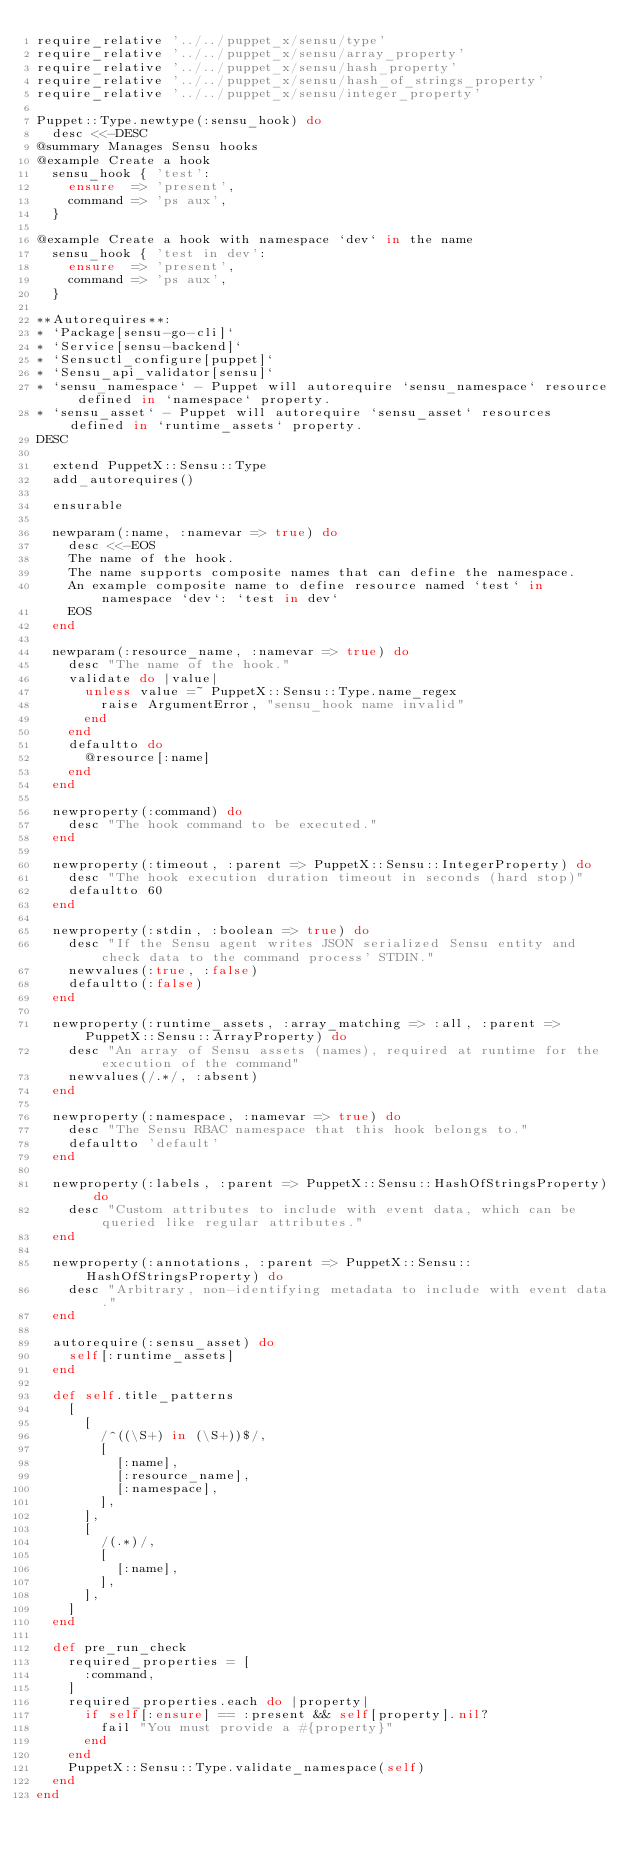Convert code to text. <code><loc_0><loc_0><loc_500><loc_500><_Ruby_>require_relative '../../puppet_x/sensu/type'
require_relative '../../puppet_x/sensu/array_property'
require_relative '../../puppet_x/sensu/hash_property'
require_relative '../../puppet_x/sensu/hash_of_strings_property'
require_relative '../../puppet_x/sensu/integer_property'

Puppet::Type.newtype(:sensu_hook) do
  desc <<-DESC
@summary Manages Sensu hooks
@example Create a hook
  sensu_hook { 'test':
    ensure  => 'present',
    command => 'ps aux',
  }

@example Create a hook with namespace `dev` in the name
  sensu_hook { 'test in dev':
    ensure  => 'present',
    command => 'ps aux',
  }

**Autorequires**:
* `Package[sensu-go-cli]`
* `Service[sensu-backend]`
* `Sensuctl_configure[puppet]`
* `Sensu_api_validator[sensu]`
* `sensu_namespace` - Puppet will autorequire `sensu_namespace` resource defined in `namespace` property.
* `sensu_asset` - Puppet will autorequire `sensu_asset` resources defined in `runtime_assets` property.
DESC

  extend PuppetX::Sensu::Type
  add_autorequires()

  ensurable

  newparam(:name, :namevar => true) do
    desc <<-EOS
    The name of the hook.
    The name supports composite names that can define the namespace.
    An example composite name to define resource named `test` in namespace `dev`: `test in dev`
    EOS
  end

  newparam(:resource_name, :namevar => true) do
    desc "The name of the hook."
    validate do |value|
      unless value =~ PuppetX::Sensu::Type.name_regex
        raise ArgumentError, "sensu_hook name invalid"
      end
    end
    defaultto do
      @resource[:name]
    end
  end

  newproperty(:command) do
    desc "The hook command to be executed."
  end

  newproperty(:timeout, :parent => PuppetX::Sensu::IntegerProperty) do
    desc "The hook execution duration timeout in seconds (hard stop)"
    defaultto 60
  end

  newproperty(:stdin, :boolean => true) do
    desc "If the Sensu agent writes JSON serialized Sensu entity and check data to the command process' STDIN."
    newvalues(:true, :false)
    defaultto(:false)
  end

  newproperty(:runtime_assets, :array_matching => :all, :parent => PuppetX::Sensu::ArrayProperty) do
    desc "An array of Sensu assets (names), required at runtime for the execution of the command"
    newvalues(/.*/, :absent)
  end

  newproperty(:namespace, :namevar => true) do
    desc "The Sensu RBAC namespace that this hook belongs to."
    defaultto 'default'
  end

  newproperty(:labels, :parent => PuppetX::Sensu::HashOfStringsProperty) do
    desc "Custom attributes to include with event data, which can be queried like regular attributes."
  end

  newproperty(:annotations, :parent => PuppetX::Sensu::HashOfStringsProperty) do
    desc "Arbitrary, non-identifying metadata to include with event data."
  end

  autorequire(:sensu_asset) do
    self[:runtime_assets]
  end

  def self.title_patterns
    [
      [
        /^((\S+) in (\S+))$/,
        [
          [:name],
          [:resource_name],
          [:namespace],
        ],
      ],
      [
        /(.*)/,
        [
          [:name],
        ],
      ],
    ]
  end

  def pre_run_check
    required_properties = [
      :command,
    ]
    required_properties.each do |property|
      if self[:ensure] == :present && self[property].nil?
        fail "You must provide a #{property}"
      end
    end
    PuppetX::Sensu::Type.validate_namespace(self)
  end
end
</code> 